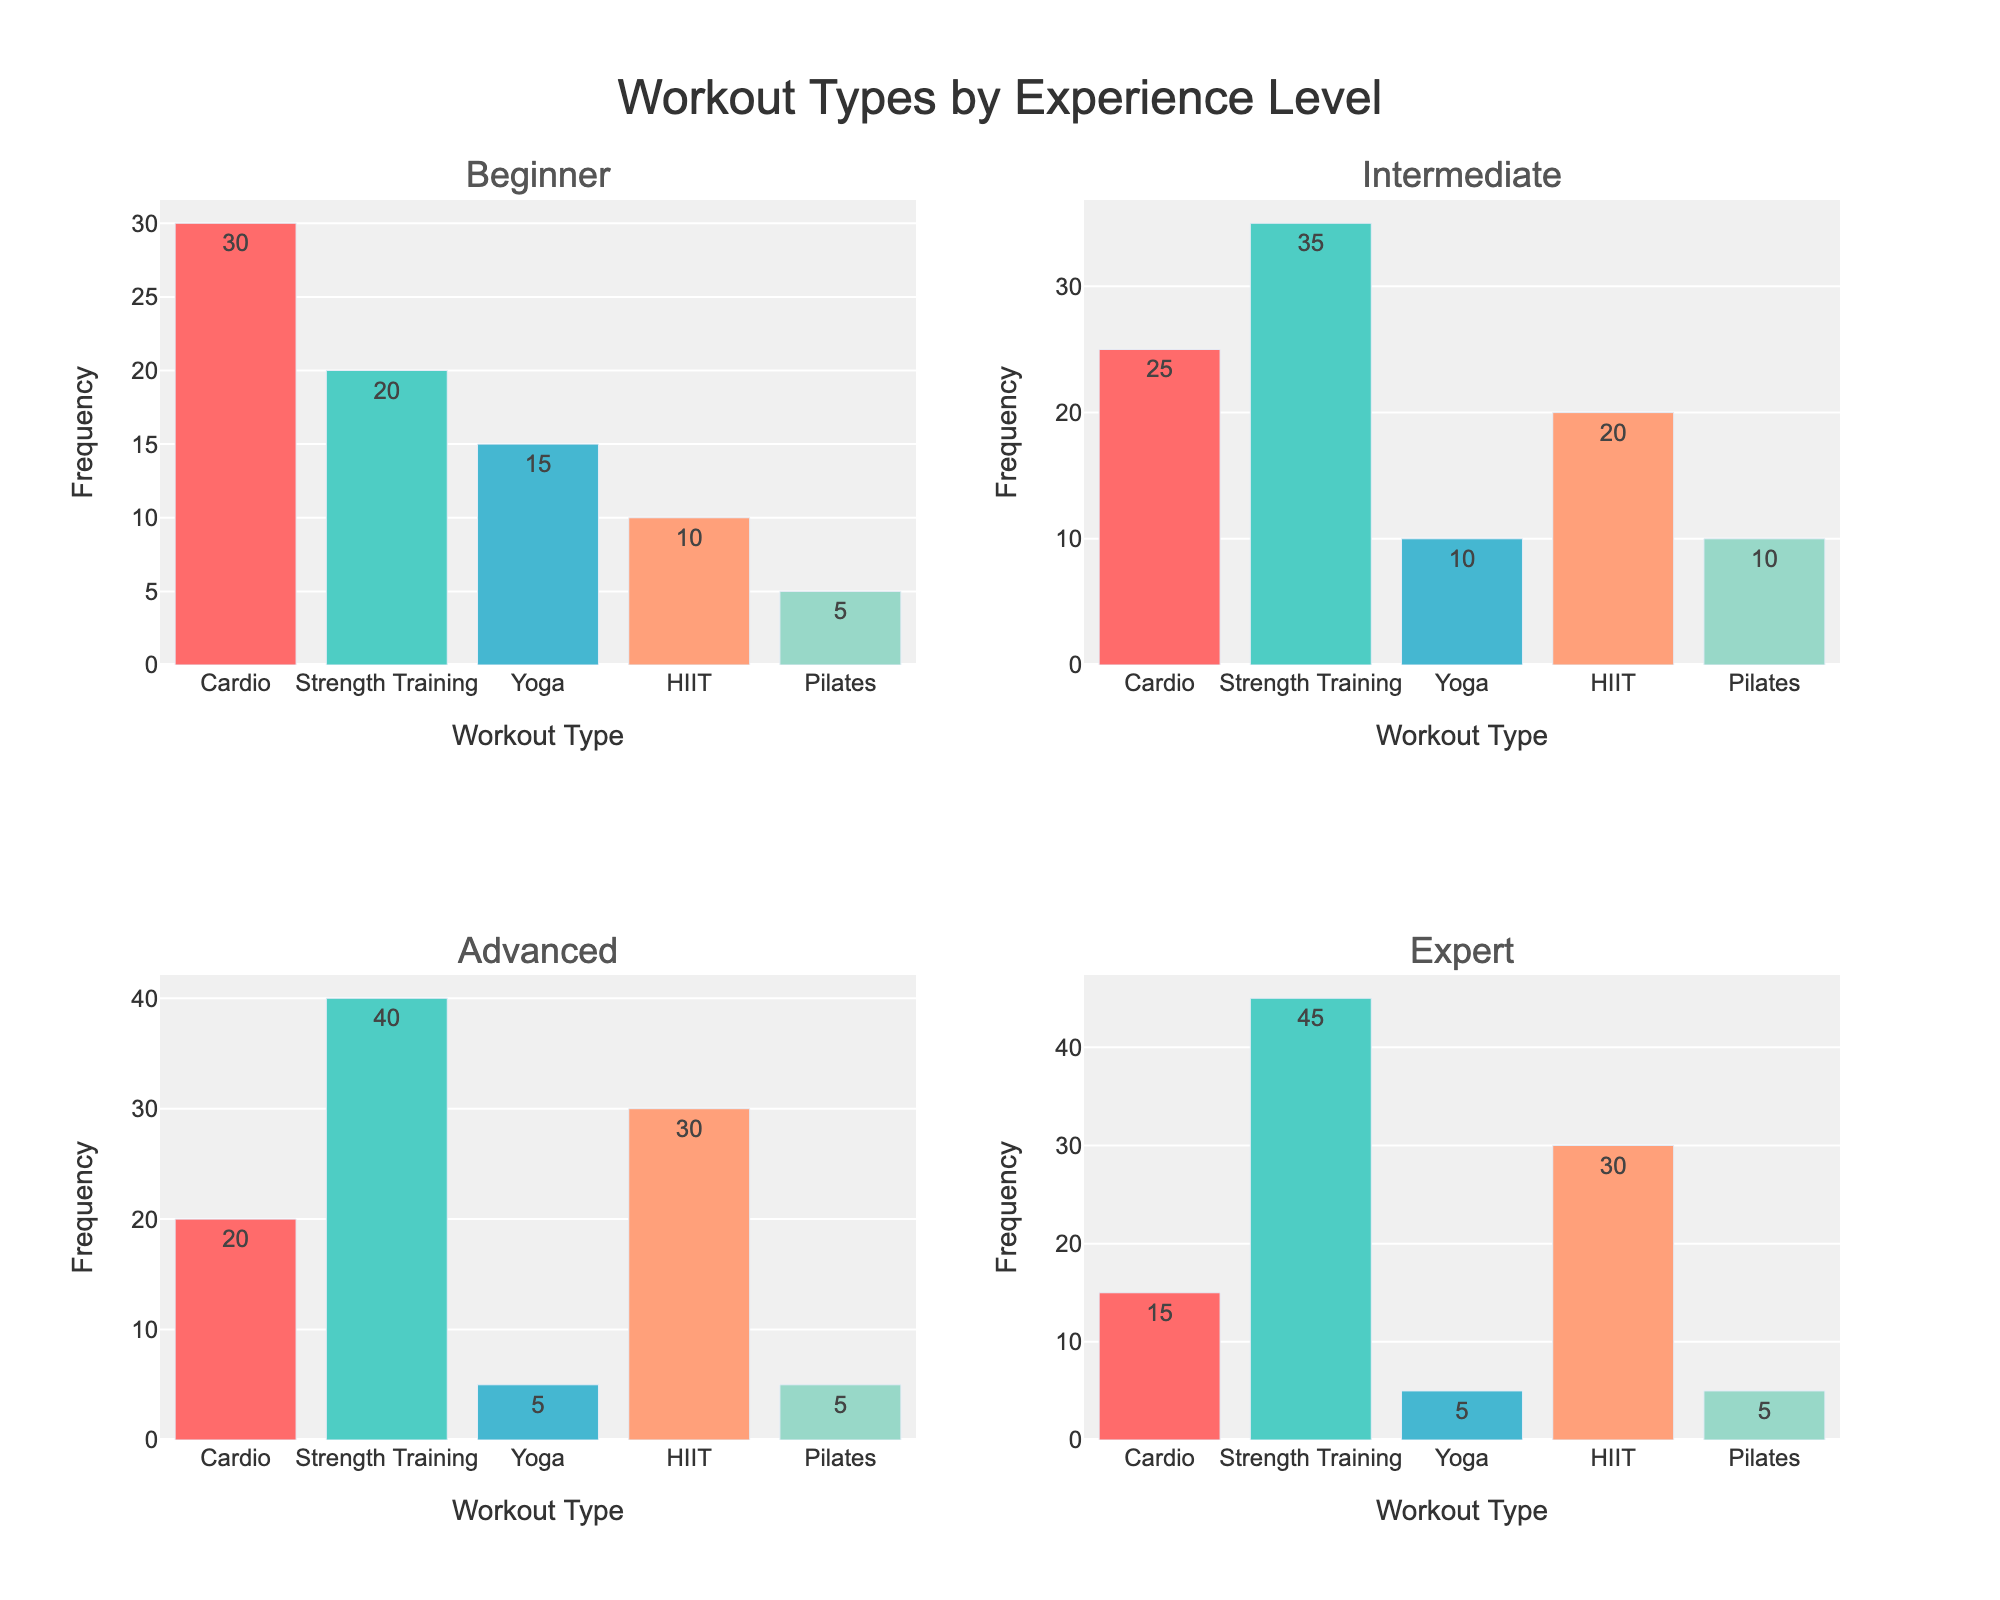What is the most frequently performed workout type among beginners? The subplot for beginners shows that Cardio has the highest frequency with a value of 30.
Answer: Cardio How does the frequency of HIIT workouts compare between beginners and experts? In the figure, HIIT for beginners shows a frequency of 10, and for experts, it shows a frequency of 30. Comparing the values, experts perform HIIT workouts more frequently than beginners.
Answer: Experts more frequently Which experience level has the highest frequency of strength training workouts? Observing each subplot, experts have the highest frequency of strength training with a value of 45.
Answer: Experts What is the total frequency of Cardio workouts across all experience levels? Summing the frequencies for Cardio from all subplots: 30 (Beginner) + 25 (Intermediate) + 20 (Advanced) + 15 (Expert) = 90.
Answer: 90 Among intermediates, which workout type has the lowest frequency? In the subplot for Intermediates, Yoga has the lowest frequency with a value of 10 compared to other workout types.
Answer: Yoga In the subplot for advanced users, which workout type frequency is greater than or equal to 20? For advanced users, Cardio (20), Strength Training (40), and HIIT (30) all have frequencies greater than or equal to 20.
Answer: Cardio, Strength Training, and HIIT What is the average frequency of Pilates workouts across all experience levels? Frequencies for Pilates are: 5 (Beginner), 10 (Intermediate), 5 (Advanced), 5 (Expert). Average is calculated as (5 + 10 + 5 + 5) / 4 = 6.25.
Answer: 6.25 How many workout types have a frequency of higher than 30 across any experience level? In all subplots, only Strength Training for Intermediate (35), Strength Training for Advanced (40), and Strength Training for Expert (45) have frequencies higher than 30.
Answer: 3 Which experience level has the most balanced frequency distribution among workout types? Examining each subplot, Intermediate shows a more balanced distribution with frequencies ranging from 10 to 35 compared to other levels where some workout types dominate significantly.
Answer: Intermediate 